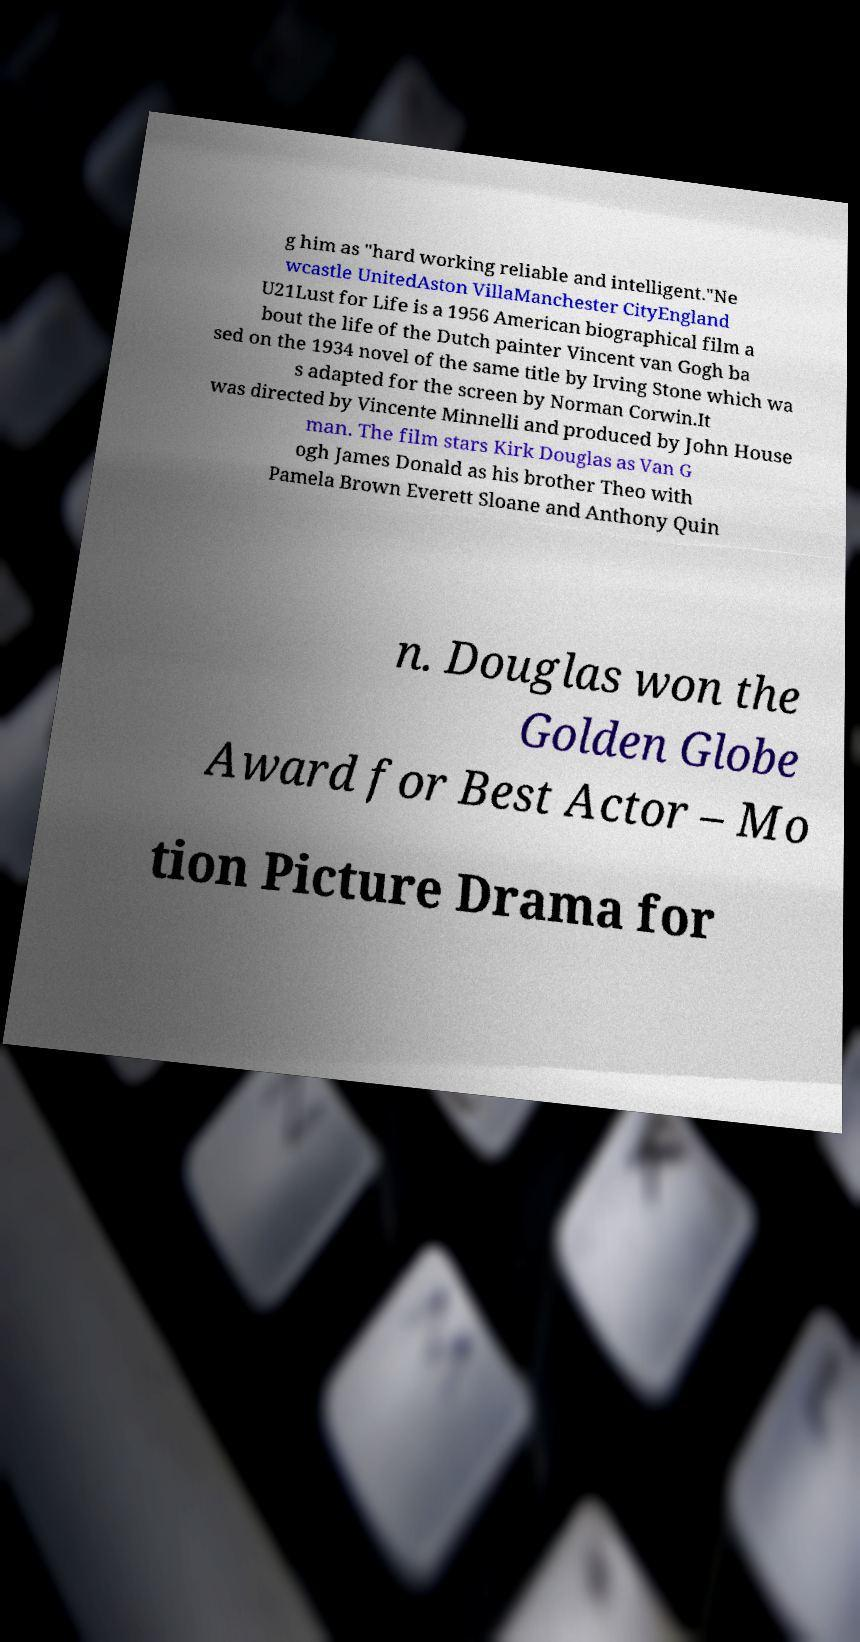Could you extract and type out the text from this image? g him as "hard working reliable and intelligent."Ne wcastle UnitedAston VillaManchester CityEngland U21Lust for Life is a 1956 American biographical film a bout the life of the Dutch painter Vincent van Gogh ba sed on the 1934 novel of the same title by Irving Stone which wa s adapted for the screen by Norman Corwin.It was directed by Vincente Minnelli and produced by John House man. The film stars Kirk Douglas as Van G ogh James Donald as his brother Theo with Pamela Brown Everett Sloane and Anthony Quin n. Douglas won the Golden Globe Award for Best Actor – Mo tion Picture Drama for 